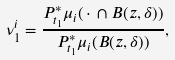<formula> <loc_0><loc_0><loc_500><loc_500>\nu ^ { i } _ { 1 } = \frac { P _ { t _ { 1 } } ^ { * } \mu _ { i } ( \, \cdot \, \cap B ( z , \delta ) ) } { P _ { t _ { 1 } } ^ { * } \mu _ { i } ( B ( z , \delta ) ) } ,</formula> 